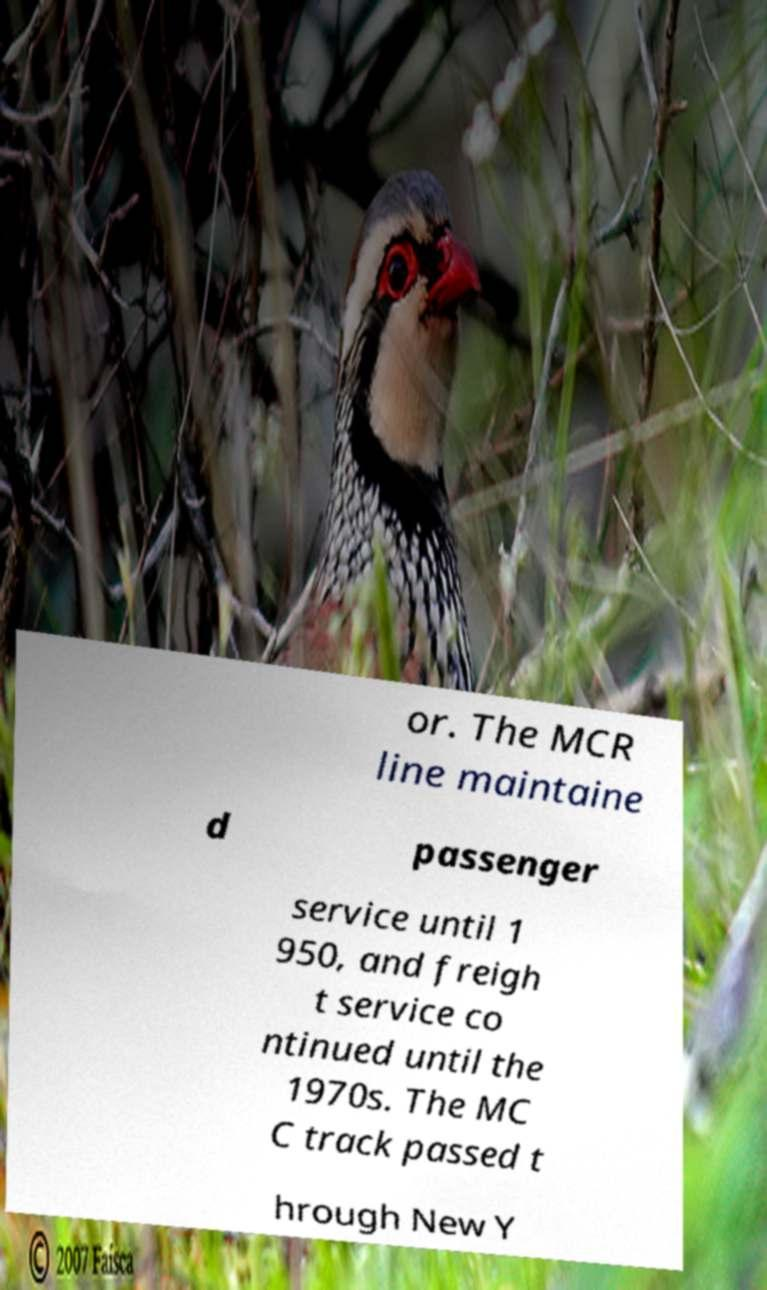What messages or text are displayed in this image? I need them in a readable, typed format. or. The MCR line maintaine d passenger service until 1 950, and freigh t service co ntinued until the 1970s. The MC C track passed t hrough New Y 